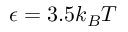Convert formula to latex. <formula><loc_0><loc_0><loc_500><loc_500>\epsilon = 3 . 5 k _ { B } T</formula> 